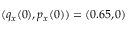<formula> <loc_0><loc_0><loc_500><loc_500>( q _ { x } ( 0 ) , p _ { x } ( 0 ) ) = ( 0 . 6 5 , 0 )</formula> 